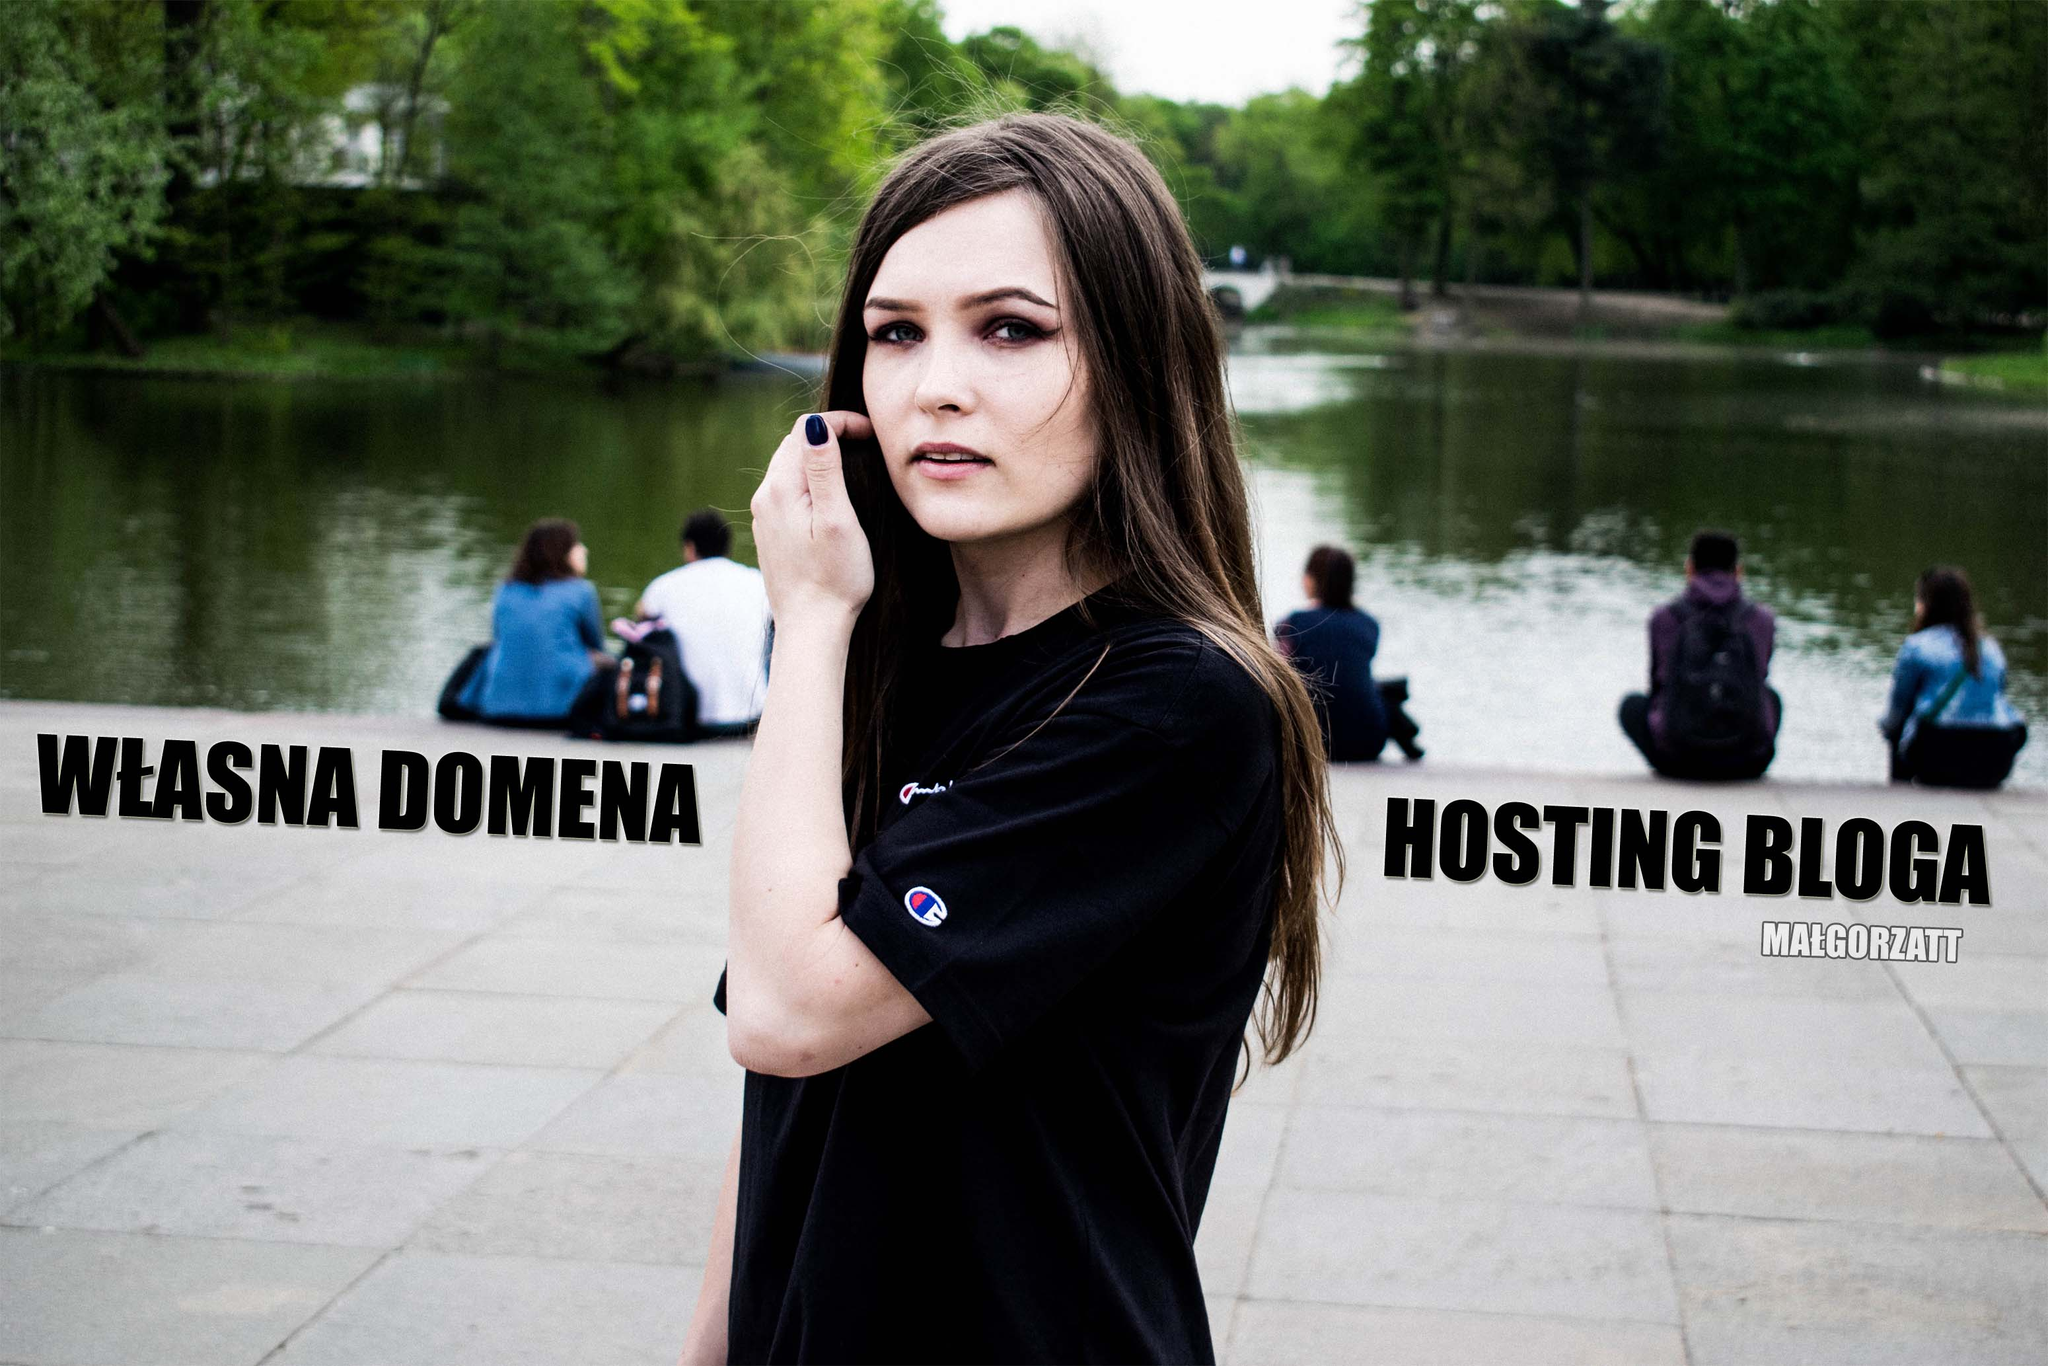Let's imagine a scenario where this image is part of a futuristic digital gallery. How might people interact with it? In a futuristic digital gallery, this image could be part of an interactive exhibit. Visitors might use augmented reality glasses to see the text animated, perhaps forming connections between different parts of the image. The woman might virtually speak to the visitors, providing insights into the importance of domain ownership and blog hosting. Touchscreens could allow them to delve deeper into related topics, learning about web hosting through immersive, hyperlinked content. This blend of visual art and technology could transform a simple image into an extensive educational experience. 